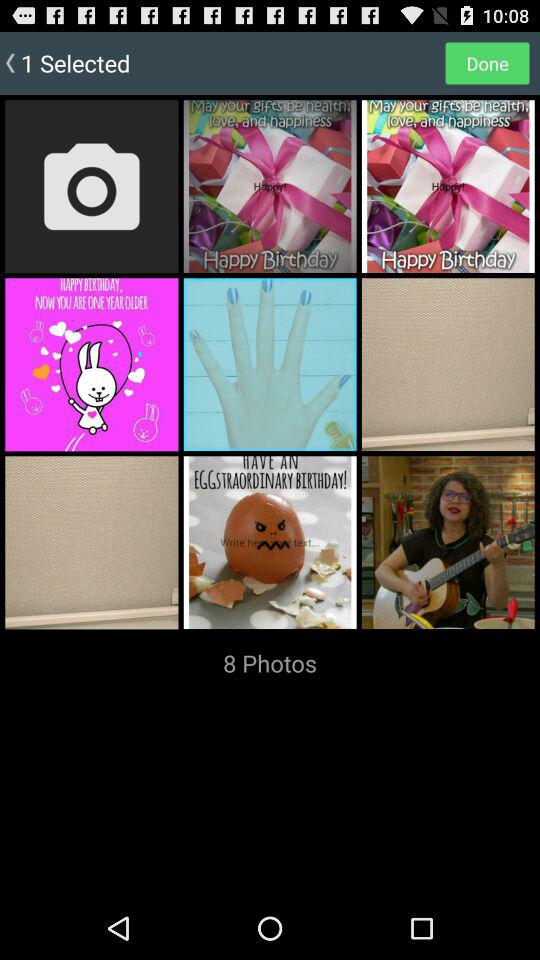How many images are selected? There is 1 image selected. 